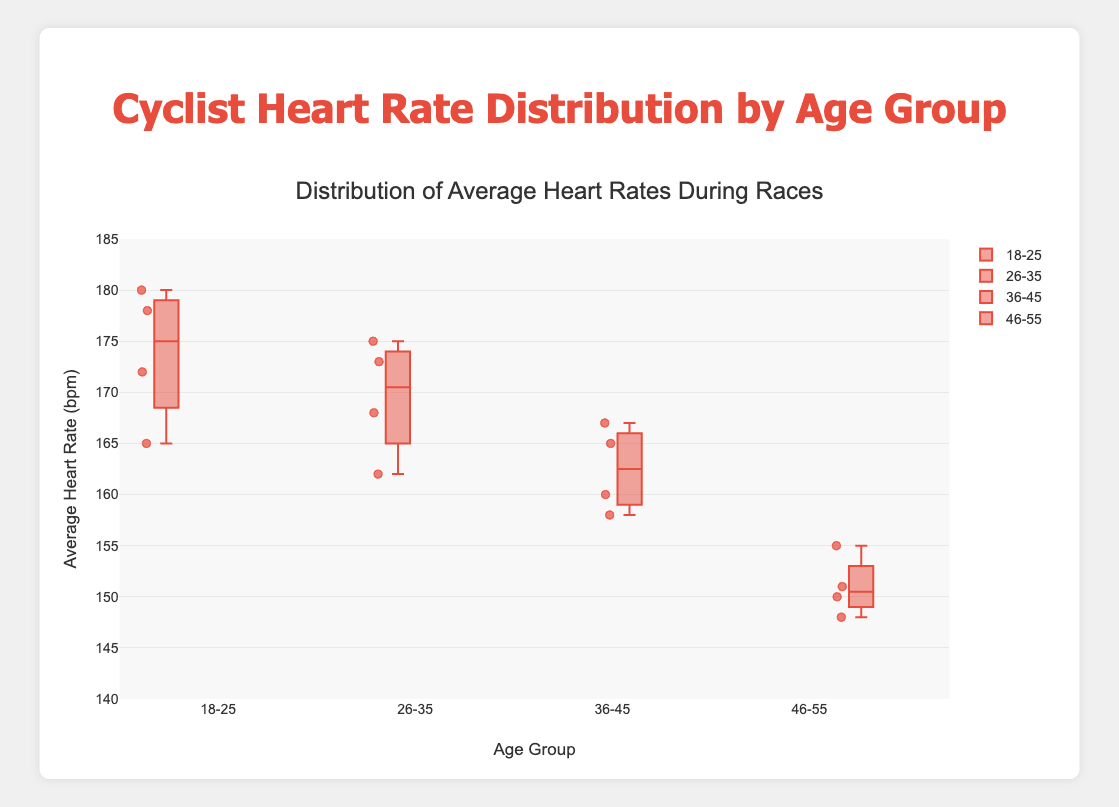What's the title of the plot? The title of the plot is prominently displayed at the top of the figure. It reads "Distribution of Average Heart Rates During Races".
Answer: Distribution of Average Heart Rates During Races What age group has the lowest median heart rate? To find the median heart rate for each age group, look at the center line in each box plot. The 46-55 age group has the lowest median heart rate.
Answer: 46-55 Which age group has the highest median heart rate? The center line within each box plot represents the median heart rate. The 18-25 age group has the highest median heart rate.
Answer: 18-25 What is the heart rate range for the 26-35 age group? The heart rate range can be determined by looking at the whiskers of the box plot for the 26-35 age group. The range is from the lowest point to the highest point of the whiskers.
Answer: 162 to 175 Compare the median heart rates between the 18-25 and 46-55 age groups. Which one is higher? To compare the medians, look at the center line in the 18-25 and 46-55 box plots. The median heart rate for the 18-25 age group is higher.
Answer: 18-25 is higher Which age group has the greatest variability in heart rates? The variability or spread can be determined by the length of the box (interquartile range) and the whiskers. The 18-25 age group shows the greatest variability.
Answer: 18-25 How many age groups are represented in the plot? Count the number of separate box plots, each representing a different age group. There are four age groups represented.
Answer: Four Are there any outliers in the data, and if so, which age group has them? Outliers are typically shown as individual points outside the whiskers. By examining the box plots, it seems there are no outliers as no data points are outside the whiskers.
Answer: No outliers What is the interquartile range (IQR) for the 36-45 age group? The interquartile range (IQR) is the distance between the first quartile (bottom of the box) and third quartile (top of the box). For 36-45, this range is 158 to 167.
Answer: 9 bpm 